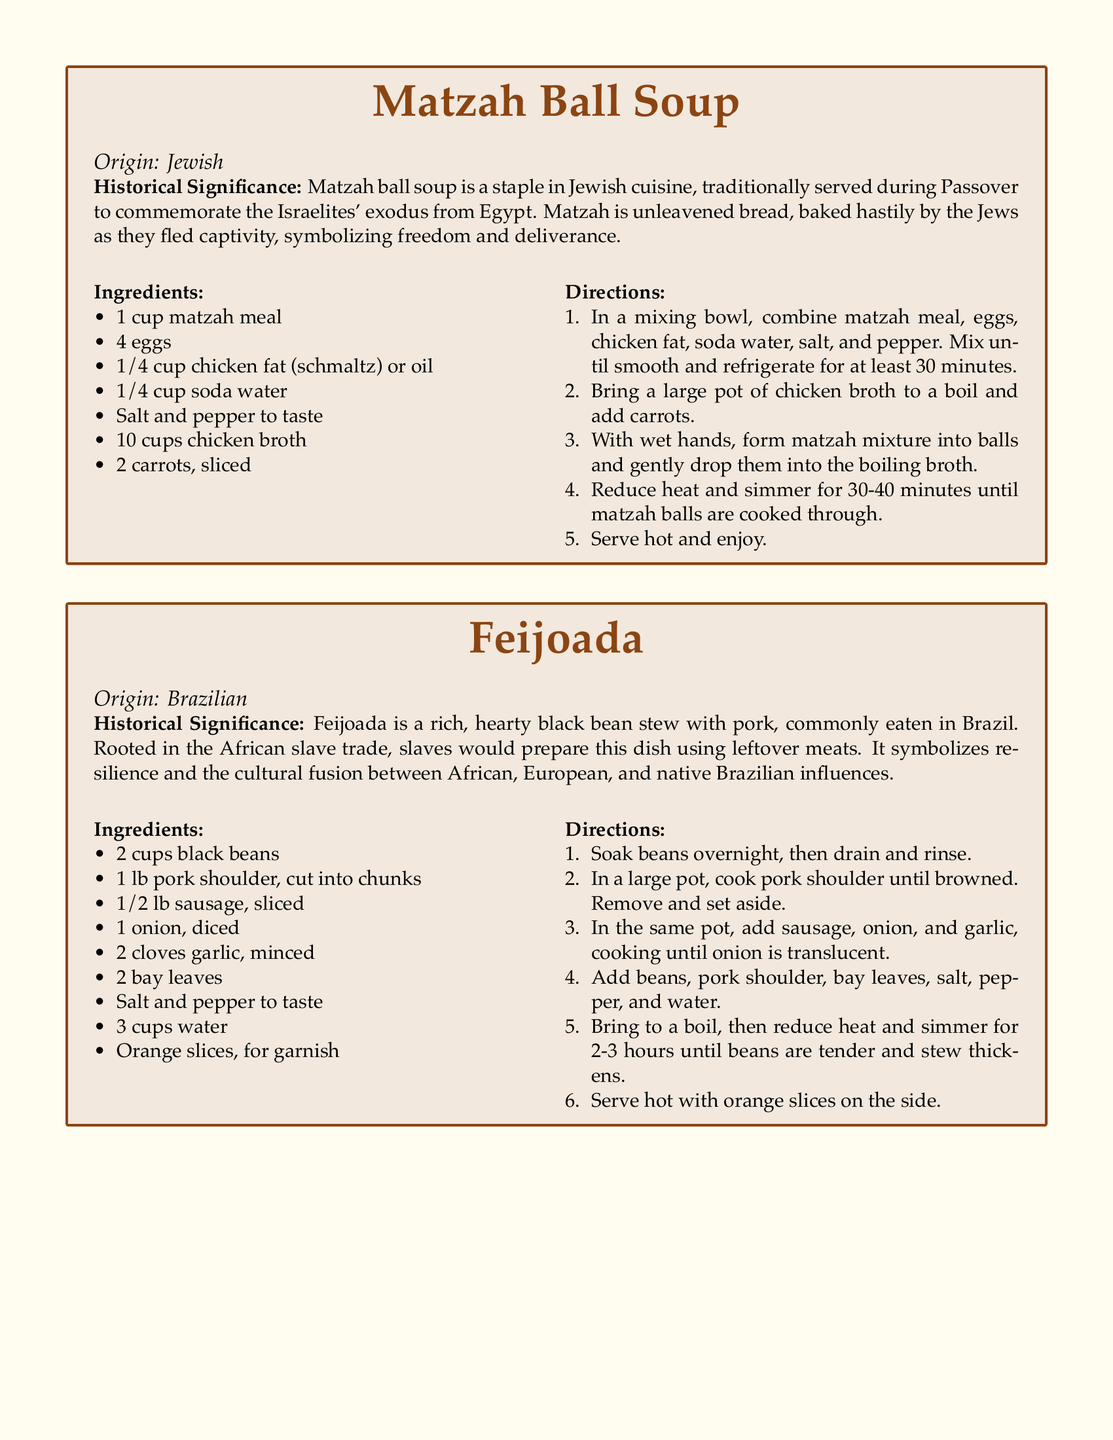What is the origin of Matzah Ball Soup? Matzah Ball Soup is identified as a Jewish dish.
Answer: Jewish What is used as a fat in the Matzah Ball Soup recipe? The recipe specifies chicken fat (schmaltz) or oil.
Answer: chicken fat (schmaltz) or oil How long should the matzah mixture be refrigerated? The directions specify refrigerating for at least 30 minutes.
Answer: 30 minutes What cultural influences does Feijoada symbolize? Feijoada symbolizes the cultural fusion between African, European, and native Brazilian influences.
Answer: African, European, and native Brazilian influences What ingredient is used to garnish Feijoada? The document states that orange slices are used for garnish.
Answer: orange slices How long does Feijoada need to simmer? The recipe indicates that Feijoada should simmer for 2-3 hours.
Answer: 2-3 hours How many cups of black beans are needed for Feijoada? The recipe lists the need for 2 cups of black beans.
Answer: 2 cups What is the historical significance of Matzah Ball Soup? Matzah Ball Soup is traditionally served during Passover to commemorate the Israelites' exodus from Egypt, symbolizing freedom and deliverance.
Answer: Easter Exodus Freedom What type of soup is Matzah Ball Soup? Matzah Ball Soup is categorized as a soup.
Answer: soup What type of dish is Feijoada? Feijoada is described as a black bean stew.
Answer: black bean stew 